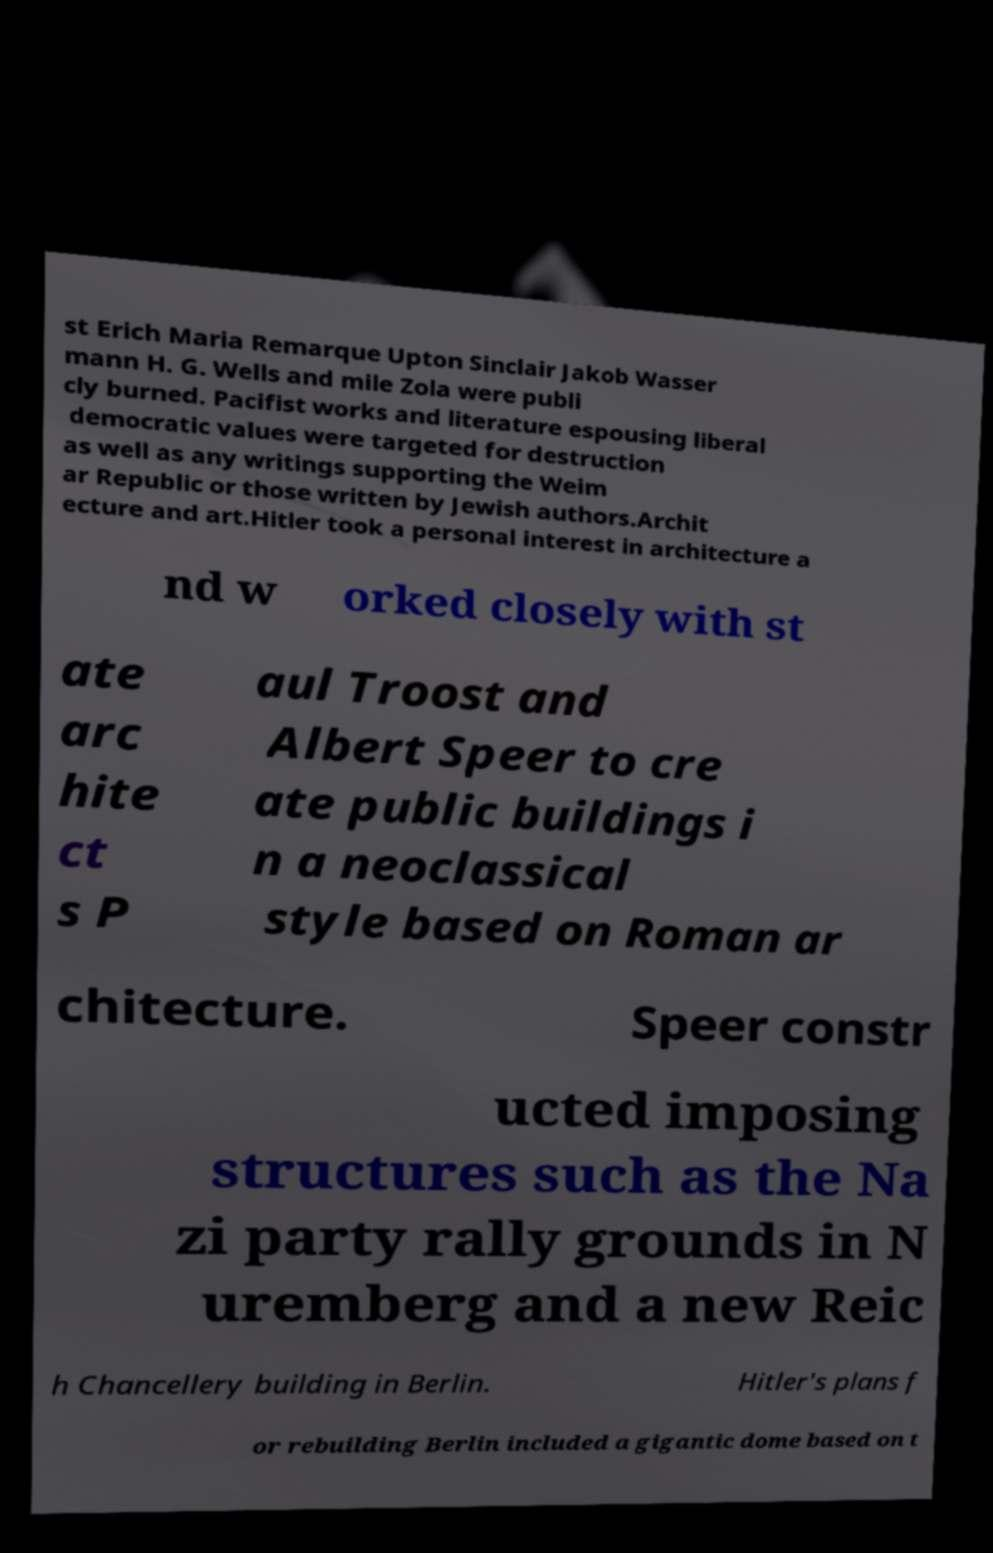There's text embedded in this image that I need extracted. Can you transcribe it verbatim? st Erich Maria Remarque Upton Sinclair Jakob Wasser mann H. G. Wells and mile Zola were publi cly burned. Pacifist works and literature espousing liberal democratic values were targeted for destruction as well as any writings supporting the Weim ar Republic or those written by Jewish authors.Archit ecture and art.Hitler took a personal interest in architecture a nd w orked closely with st ate arc hite ct s P aul Troost and Albert Speer to cre ate public buildings i n a neoclassical style based on Roman ar chitecture. Speer constr ucted imposing structures such as the Na zi party rally grounds in N uremberg and a new Reic h Chancellery building in Berlin. Hitler's plans f or rebuilding Berlin included a gigantic dome based on t 